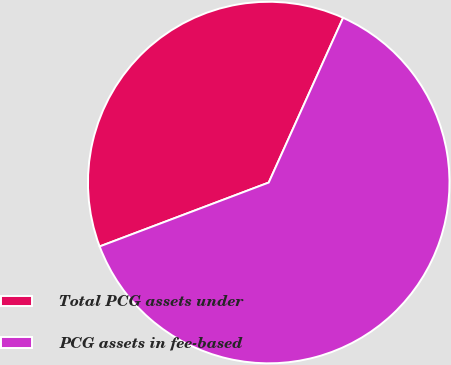Convert chart to OTSL. <chart><loc_0><loc_0><loc_500><loc_500><pie_chart><fcel>Total PCG assets under<fcel>PCG assets in fee-based<nl><fcel>37.5%<fcel>62.5%<nl></chart> 